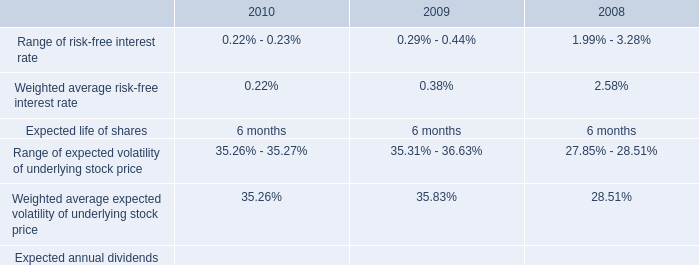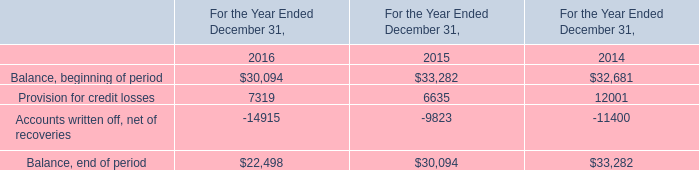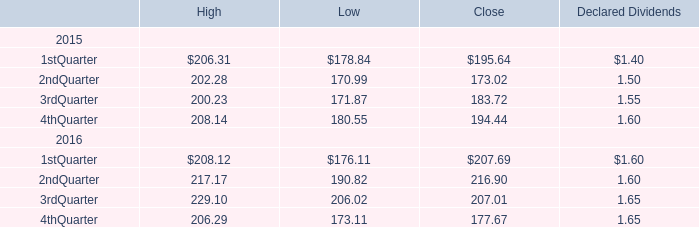What is the sum of 1stQuarter , 2ndQuarter and 3rdQuarter in 2015 for Low? 
Computations: ((178.84 + 170.99) + 171.87)
Answer: 521.7. 